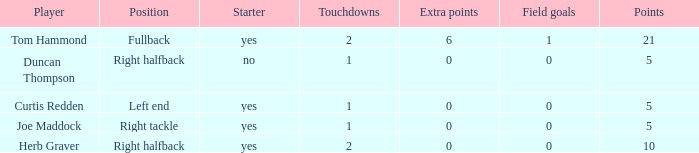Name the fewest touchdowns 1.0. 